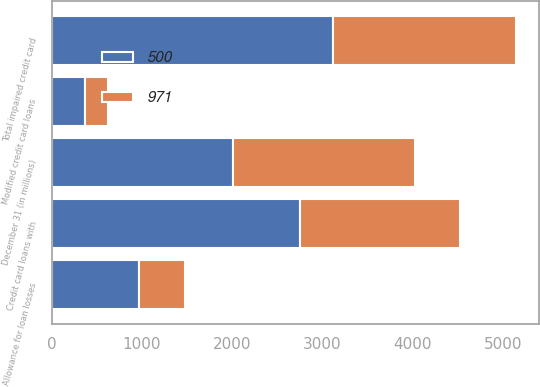<chart> <loc_0><loc_0><loc_500><loc_500><stacked_bar_chart><ecel><fcel>December 31 (in millions)<fcel>Credit card loans with<fcel>Modified credit card loans<fcel>Total impaired credit card<fcel>Allowance for loan losses<nl><fcel>971<fcel>2014<fcel>1775<fcel>254<fcel>2029<fcel>500<nl><fcel>500<fcel>2013<fcel>2746<fcel>369<fcel>3115<fcel>971<nl></chart> 